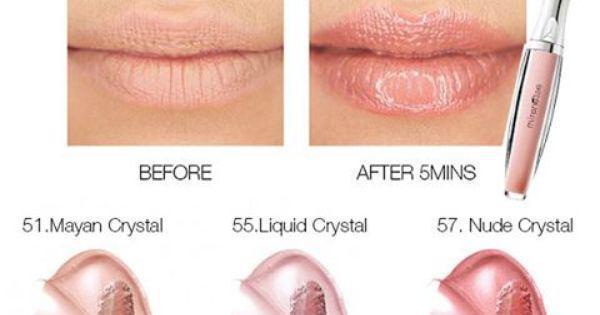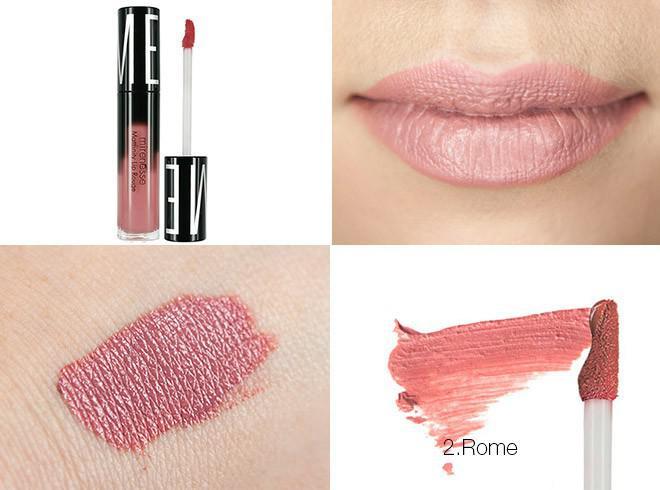The first image is the image on the left, the second image is the image on the right. Considering the images on both sides, is "there is exactly one pair of lips in the image on the left" valid? Answer yes or no. No. The first image is the image on the left, the second image is the image on the right. Analyze the images presented: Is the assertion "Left image shows a pink lipstick with cap on, and image of glossy lips." valid? Answer yes or no. Yes. 